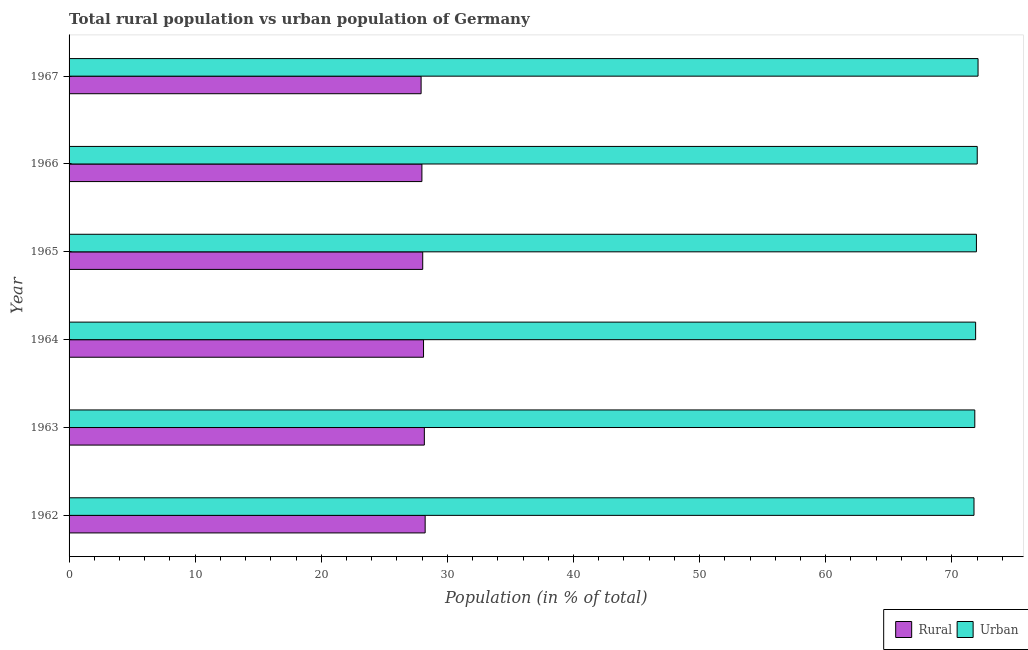How many groups of bars are there?
Provide a succinct answer. 6. How many bars are there on the 1st tick from the top?
Ensure brevity in your answer.  2. How many bars are there on the 1st tick from the bottom?
Your answer should be compact. 2. What is the label of the 4th group of bars from the top?
Offer a terse response. 1964. What is the rural population in 1965?
Provide a succinct answer. 28.05. Across all years, what is the maximum rural population?
Make the answer very short. 28.24. Across all years, what is the minimum rural population?
Your response must be concise. 27.92. In which year was the rural population minimum?
Offer a terse response. 1967. What is the total rural population in the graph?
Give a very brief answer. 168.46. What is the difference between the urban population in 1963 and that in 1965?
Keep it short and to the point. -0.13. What is the difference between the urban population in 1962 and the rural population in 1964?
Offer a very short reply. 43.65. What is the average urban population per year?
Your response must be concise. 71.92. In the year 1963, what is the difference between the rural population and urban population?
Ensure brevity in your answer.  -43.65. In how many years, is the urban population greater than 2 %?
Make the answer very short. 6. Is the urban population in 1963 less than that in 1964?
Your response must be concise. Yes. Is the difference between the urban population in 1963 and 1966 greater than the difference between the rural population in 1963 and 1966?
Provide a succinct answer. No. What is the difference between the highest and the second highest rural population?
Offer a very short reply. 0.06. What is the difference between the highest and the lowest urban population?
Keep it short and to the point. 0.32. What does the 1st bar from the top in 1965 represents?
Give a very brief answer. Urban. What does the 2nd bar from the bottom in 1966 represents?
Offer a very short reply. Urban. How many bars are there?
Your response must be concise. 12. Are the values on the major ticks of X-axis written in scientific E-notation?
Offer a terse response. No. Where does the legend appear in the graph?
Give a very brief answer. Bottom right. What is the title of the graph?
Give a very brief answer. Total rural population vs urban population of Germany. What is the label or title of the X-axis?
Make the answer very short. Population (in % of total). What is the Population (in % of total) in Rural in 1962?
Provide a short and direct response. 28.24. What is the Population (in % of total) of Urban in 1962?
Offer a very short reply. 71.76. What is the Population (in % of total) in Rural in 1963?
Your response must be concise. 28.17. What is the Population (in % of total) in Urban in 1963?
Provide a succinct answer. 71.83. What is the Population (in % of total) in Rural in 1964?
Make the answer very short. 28.11. What is the Population (in % of total) in Urban in 1964?
Provide a succinct answer. 71.89. What is the Population (in % of total) in Rural in 1965?
Your answer should be compact. 28.05. What is the Population (in % of total) in Urban in 1965?
Ensure brevity in your answer.  71.95. What is the Population (in % of total) of Rural in 1966?
Offer a terse response. 27.98. What is the Population (in % of total) of Urban in 1966?
Your answer should be compact. 72.02. What is the Population (in % of total) in Rural in 1967?
Ensure brevity in your answer.  27.92. What is the Population (in % of total) in Urban in 1967?
Your answer should be compact. 72.08. Across all years, what is the maximum Population (in % of total) of Rural?
Keep it short and to the point. 28.24. Across all years, what is the maximum Population (in % of total) of Urban?
Keep it short and to the point. 72.08. Across all years, what is the minimum Population (in % of total) of Rural?
Keep it short and to the point. 27.92. Across all years, what is the minimum Population (in % of total) in Urban?
Your answer should be very brief. 71.76. What is the total Population (in % of total) in Rural in the graph?
Provide a succinct answer. 168.46. What is the total Population (in % of total) in Urban in the graph?
Your answer should be very brief. 431.54. What is the difference between the Population (in % of total) in Rural in 1962 and that in 1963?
Offer a terse response. 0.06. What is the difference between the Population (in % of total) of Urban in 1962 and that in 1963?
Your response must be concise. -0.06. What is the difference between the Population (in % of total) of Rural in 1962 and that in 1964?
Your answer should be compact. 0.13. What is the difference between the Population (in % of total) of Urban in 1962 and that in 1964?
Your answer should be compact. -0.13. What is the difference between the Population (in % of total) of Rural in 1962 and that in 1965?
Keep it short and to the point. 0.19. What is the difference between the Population (in % of total) of Urban in 1962 and that in 1965?
Your response must be concise. -0.19. What is the difference between the Population (in % of total) in Rural in 1962 and that in 1966?
Provide a short and direct response. 0.26. What is the difference between the Population (in % of total) in Urban in 1962 and that in 1966?
Make the answer very short. -0.26. What is the difference between the Population (in % of total) of Rural in 1962 and that in 1967?
Make the answer very short. 0.32. What is the difference between the Population (in % of total) in Urban in 1962 and that in 1967?
Provide a short and direct response. -0.32. What is the difference between the Population (in % of total) in Rural in 1963 and that in 1964?
Your response must be concise. 0.07. What is the difference between the Population (in % of total) of Urban in 1963 and that in 1964?
Give a very brief answer. -0.07. What is the difference between the Population (in % of total) of Rural in 1963 and that in 1965?
Ensure brevity in your answer.  0.13. What is the difference between the Population (in % of total) in Urban in 1963 and that in 1965?
Your answer should be compact. -0.13. What is the difference between the Population (in % of total) in Rural in 1963 and that in 1966?
Give a very brief answer. 0.19. What is the difference between the Population (in % of total) in Urban in 1963 and that in 1966?
Make the answer very short. -0.19. What is the difference between the Population (in % of total) in Rural in 1963 and that in 1967?
Ensure brevity in your answer.  0.26. What is the difference between the Population (in % of total) in Urban in 1963 and that in 1967?
Keep it short and to the point. -0.26. What is the difference between the Population (in % of total) of Rural in 1964 and that in 1965?
Your response must be concise. 0.06. What is the difference between the Population (in % of total) in Urban in 1964 and that in 1965?
Your answer should be compact. -0.06. What is the difference between the Population (in % of total) in Rural in 1964 and that in 1966?
Your answer should be very brief. 0.13. What is the difference between the Population (in % of total) of Urban in 1964 and that in 1966?
Your answer should be compact. -0.13. What is the difference between the Population (in % of total) in Rural in 1964 and that in 1967?
Your response must be concise. 0.19. What is the difference between the Population (in % of total) of Urban in 1964 and that in 1967?
Provide a short and direct response. -0.19. What is the difference between the Population (in % of total) of Rural in 1965 and that in 1966?
Make the answer very short. 0.06. What is the difference between the Population (in % of total) in Urban in 1965 and that in 1966?
Keep it short and to the point. -0.06. What is the difference between the Population (in % of total) in Rural in 1965 and that in 1967?
Your answer should be compact. 0.13. What is the difference between the Population (in % of total) of Urban in 1965 and that in 1967?
Provide a short and direct response. -0.13. What is the difference between the Population (in % of total) in Rural in 1966 and that in 1967?
Your answer should be very brief. 0.06. What is the difference between the Population (in % of total) in Urban in 1966 and that in 1967?
Give a very brief answer. -0.06. What is the difference between the Population (in % of total) in Rural in 1962 and the Population (in % of total) in Urban in 1963?
Your response must be concise. -43.59. What is the difference between the Population (in % of total) of Rural in 1962 and the Population (in % of total) of Urban in 1964?
Offer a terse response. -43.65. What is the difference between the Population (in % of total) of Rural in 1962 and the Population (in % of total) of Urban in 1965?
Ensure brevity in your answer.  -43.72. What is the difference between the Population (in % of total) of Rural in 1962 and the Population (in % of total) of Urban in 1966?
Keep it short and to the point. -43.78. What is the difference between the Population (in % of total) of Rural in 1962 and the Population (in % of total) of Urban in 1967?
Your answer should be compact. -43.84. What is the difference between the Population (in % of total) in Rural in 1963 and the Population (in % of total) in Urban in 1964?
Your answer should be very brief. -43.72. What is the difference between the Population (in % of total) in Rural in 1963 and the Population (in % of total) in Urban in 1965?
Provide a short and direct response. -43.78. What is the difference between the Population (in % of total) of Rural in 1963 and the Population (in % of total) of Urban in 1966?
Ensure brevity in your answer.  -43.84. What is the difference between the Population (in % of total) of Rural in 1963 and the Population (in % of total) of Urban in 1967?
Ensure brevity in your answer.  -43.91. What is the difference between the Population (in % of total) in Rural in 1964 and the Population (in % of total) in Urban in 1965?
Keep it short and to the point. -43.85. What is the difference between the Population (in % of total) in Rural in 1964 and the Population (in % of total) in Urban in 1966?
Your response must be concise. -43.91. What is the difference between the Population (in % of total) of Rural in 1964 and the Population (in % of total) of Urban in 1967?
Give a very brief answer. -43.97. What is the difference between the Population (in % of total) in Rural in 1965 and the Population (in % of total) in Urban in 1966?
Provide a short and direct response. -43.97. What is the difference between the Population (in % of total) in Rural in 1965 and the Population (in % of total) in Urban in 1967?
Offer a very short reply. -44.04. What is the difference between the Population (in % of total) in Rural in 1966 and the Population (in % of total) in Urban in 1967?
Provide a succinct answer. -44.1. What is the average Population (in % of total) in Rural per year?
Provide a succinct answer. 28.08. What is the average Population (in % of total) in Urban per year?
Provide a succinct answer. 71.92. In the year 1962, what is the difference between the Population (in % of total) of Rural and Population (in % of total) of Urban?
Ensure brevity in your answer.  -43.52. In the year 1963, what is the difference between the Population (in % of total) in Rural and Population (in % of total) in Urban?
Provide a short and direct response. -43.65. In the year 1964, what is the difference between the Population (in % of total) in Rural and Population (in % of total) in Urban?
Ensure brevity in your answer.  -43.78. In the year 1965, what is the difference between the Population (in % of total) of Rural and Population (in % of total) of Urban?
Offer a terse response. -43.91. In the year 1966, what is the difference between the Population (in % of total) in Rural and Population (in % of total) in Urban?
Offer a very short reply. -44.04. In the year 1967, what is the difference between the Population (in % of total) in Rural and Population (in % of total) in Urban?
Provide a short and direct response. -44.17. What is the ratio of the Population (in % of total) of Rural in 1962 to that in 1966?
Keep it short and to the point. 1.01. What is the ratio of the Population (in % of total) of Rural in 1962 to that in 1967?
Your answer should be very brief. 1.01. What is the ratio of the Population (in % of total) of Urban in 1962 to that in 1967?
Keep it short and to the point. 1. What is the ratio of the Population (in % of total) of Rural in 1963 to that in 1967?
Make the answer very short. 1.01. What is the ratio of the Population (in % of total) in Urban in 1965 to that in 1966?
Ensure brevity in your answer.  1. What is the ratio of the Population (in % of total) of Rural in 1965 to that in 1967?
Give a very brief answer. 1. What is the ratio of the Population (in % of total) of Urban in 1965 to that in 1967?
Provide a short and direct response. 1. What is the ratio of the Population (in % of total) in Rural in 1966 to that in 1967?
Make the answer very short. 1. What is the ratio of the Population (in % of total) of Urban in 1966 to that in 1967?
Keep it short and to the point. 1. What is the difference between the highest and the second highest Population (in % of total) in Rural?
Offer a very short reply. 0.06. What is the difference between the highest and the second highest Population (in % of total) in Urban?
Your answer should be compact. 0.06. What is the difference between the highest and the lowest Population (in % of total) of Rural?
Ensure brevity in your answer.  0.32. What is the difference between the highest and the lowest Population (in % of total) in Urban?
Your response must be concise. 0.32. 